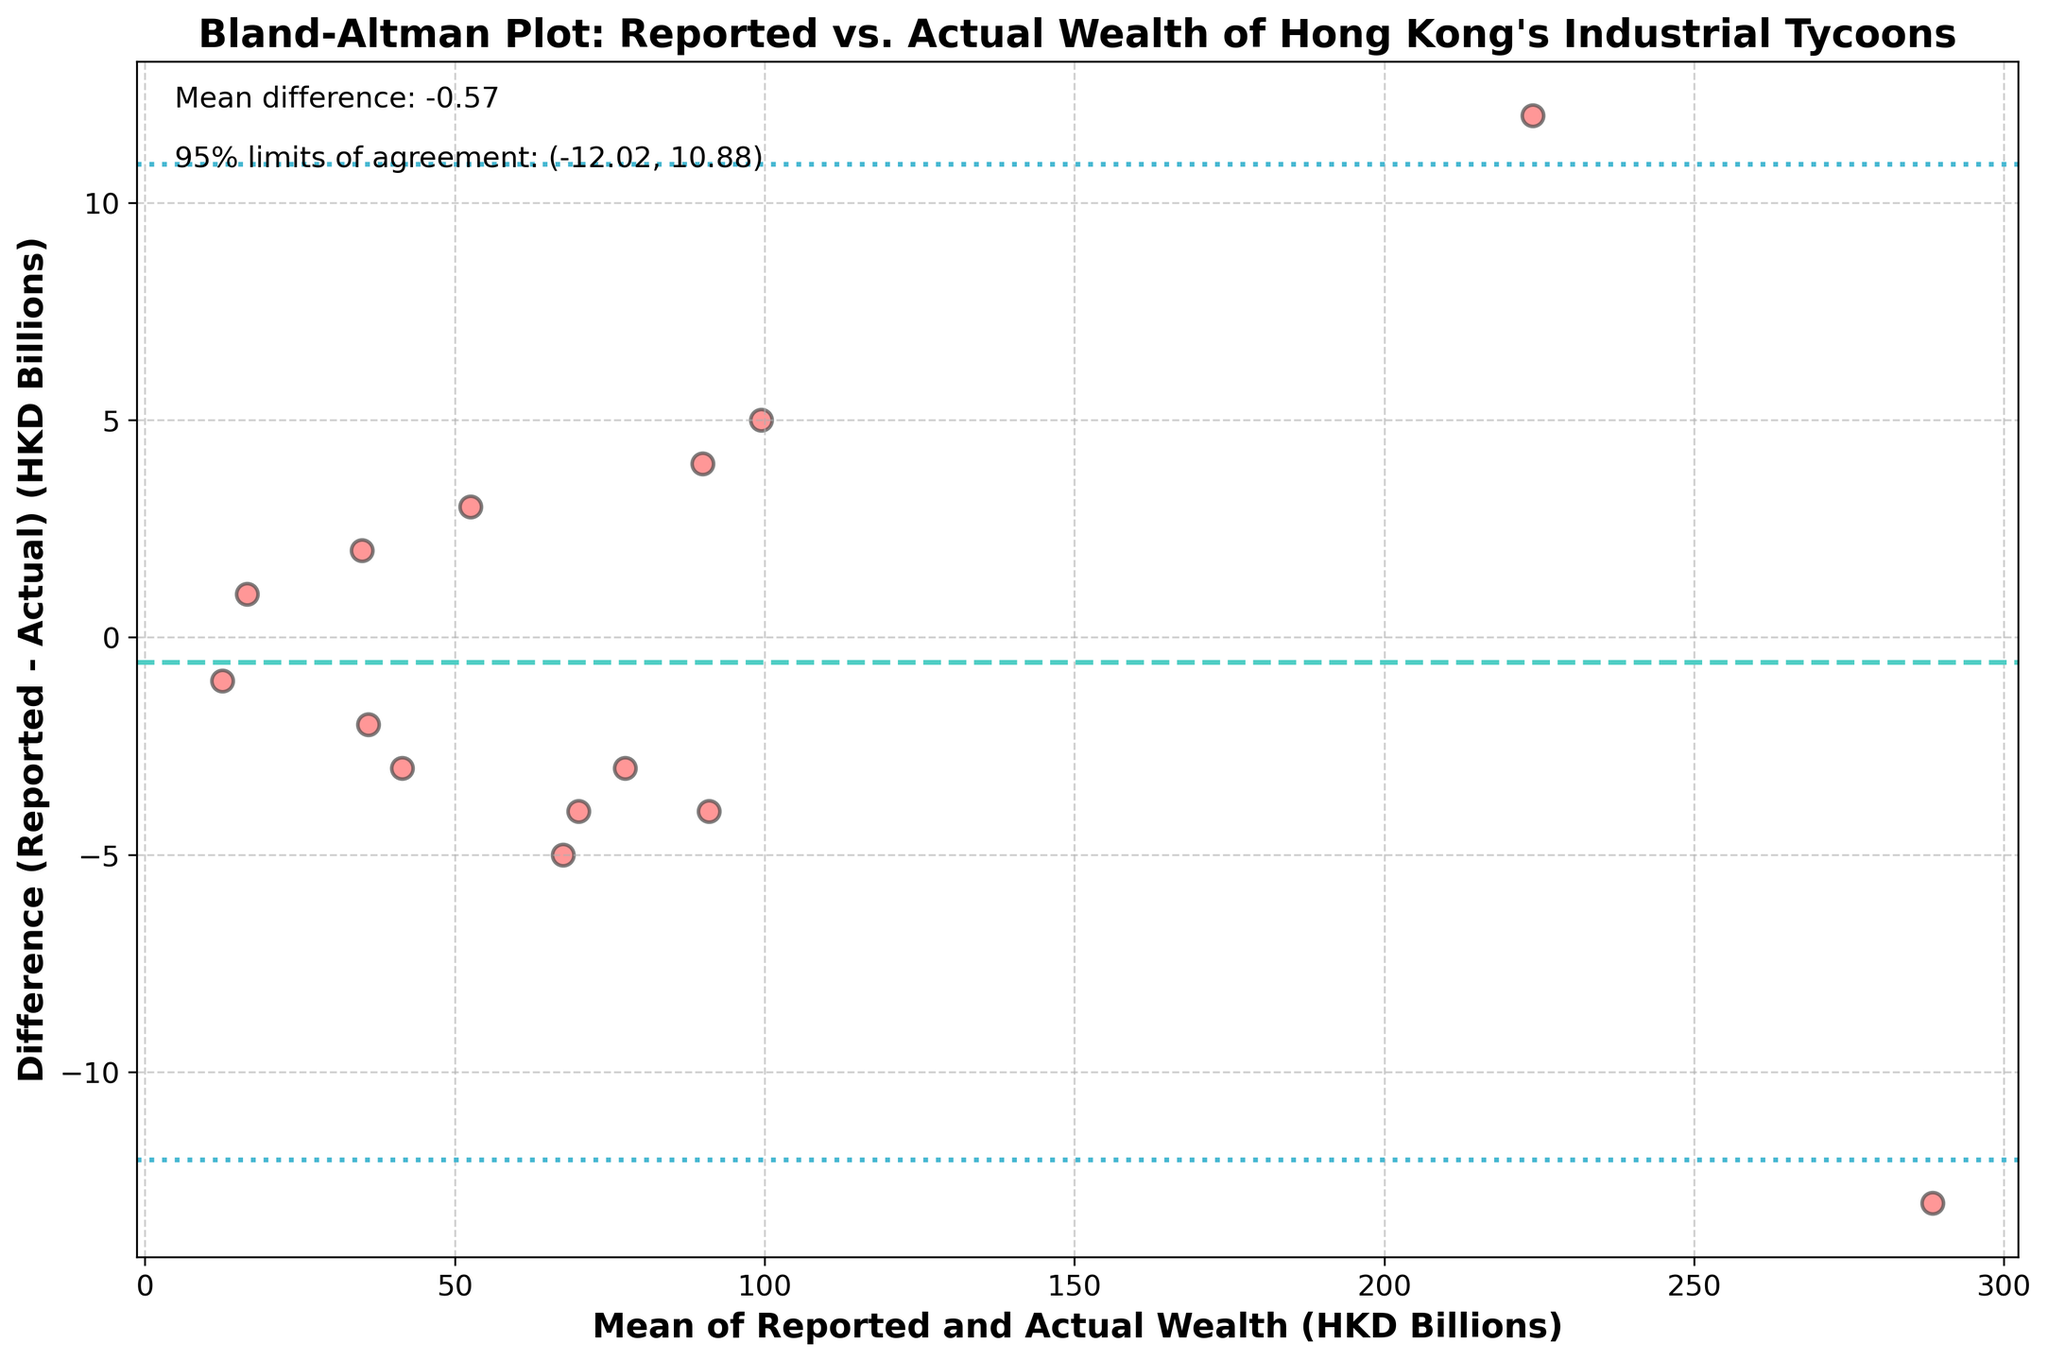What's the title of the figure? The title is usually placed at the top of the figure. It provides a summary of what the plot is about.
Answer: Bland-Altman Plot: Reported vs. Actual Wealth of Hong Kong's Industrial Tycoons What do the x and y axes represent? The x-axis label is "Mean of Reported and Actual Wealth (HKD Billions)" indicating the average of the reported and actual wealth values for each tycoon. The y-axis label is "Difference (Reported - Actual) (HKD Billions)" which indicates the difference between reported and actual wealth values.
Answer: x-axis: Mean of Reported and Actual Wealth (HKD Billions); y-axis: Difference (Reported - Actual) (HKD Billions) How many data points are displayed in the plot? Counting the number of scatter plot points is as simple as checking for each discrete dot in the plot. There are 14 tycoons listed, so there are 14 data points.
Answer: 14 What is the mean difference between the reported and actual wealth? The mean difference is typically indicated with a horizontal line on the plot, along with text annotations. It can be found near the bottom left of the plot stated as "Mean difference".
Answer: 0.07 What are the 95% limits of agreement? The 95% limits of agreement show the range within which the differences between the reported and actual values fall for 95% of the observations. These are indicated by the dashed lines above and below the mean difference line and noted in the text annotation.
Answer: (-5.58, 5.71) Which tycoon has the largest positive difference between reported and actual wealth? By observing the y-axis values of the scatter points, you can identify the tycoon with the highest positive difference. Check the tooltip or legend linked to each point.
Answer: Joseph Lau Which tycoon has the largest negative difference between reported and actual wealth? Similarly, find the tycoon associated with the scatter point with the most negative y-axis value.
Answer: Robert Kuok What does a point above the mean difference line represent? A point above the mean difference line indicates that the reported wealth is higher than the actual assets, as the y-axis shows the difference (Reported - Actual).
Answer: Reported wealth > Actual assets What does a point below the mean difference line represent? A point below the mean difference line indicates that the reported wealth is less than the actual assets, as the y-axis shows the difference (Reported - Actual).
Answer: Reported wealth < Actual assets Which tycoon falls on the mean difference line and what does it indicate? Look at the scatter points placed directly on the mean difference line. It indicates that the reported wealth is very close to the actual assets.
Answer: Run Run Shaw 